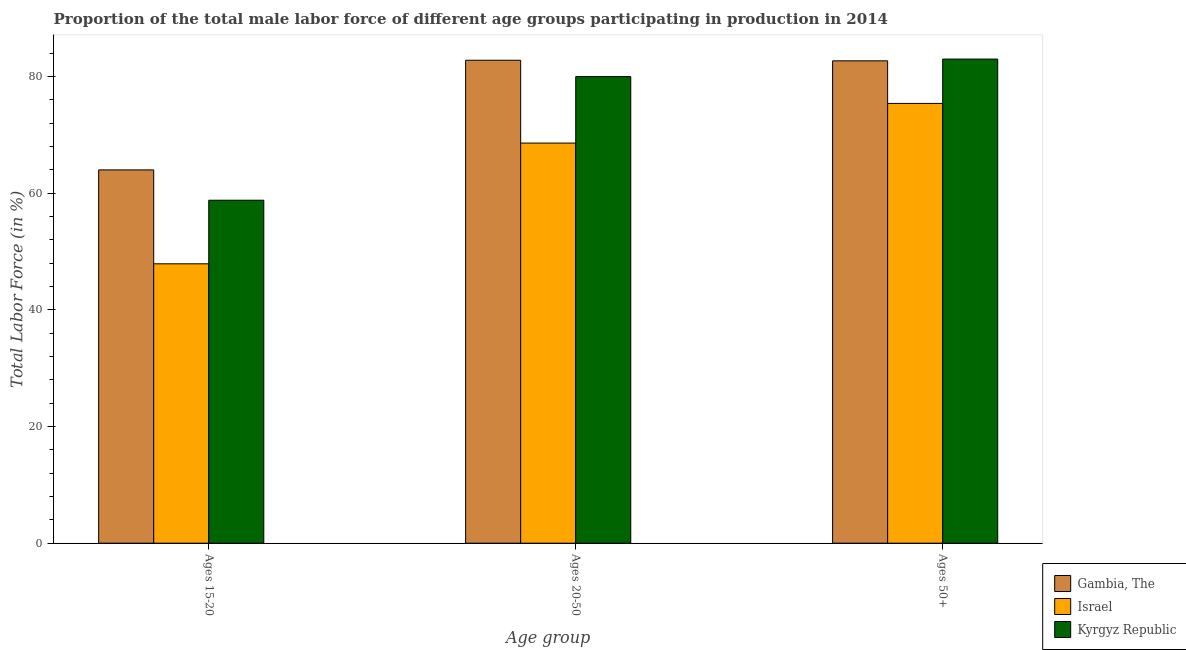Are the number of bars per tick equal to the number of legend labels?
Make the answer very short. Yes. Are the number of bars on each tick of the X-axis equal?
Make the answer very short. Yes. How many bars are there on the 1st tick from the left?
Your response must be concise. 3. How many bars are there on the 2nd tick from the right?
Keep it short and to the point. 3. What is the label of the 1st group of bars from the left?
Ensure brevity in your answer.  Ages 15-20. What is the percentage of male labor force within the age group 15-20 in Kyrgyz Republic?
Your answer should be compact. 58.8. Across all countries, what is the maximum percentage of male labor force within the age group 20-50?
Offer a terse response. 82.8. Across all countries, what is the minimum percentage of male labor force above age 50?
Your response must be concise. 75.4. In which country was the percentage of male labor force above age 50 maximum?
Your answer should be compact. Kyrgyz Republic. In which country was the percentage of male labor force within the age group 15-20 minimum?
Your response must be concise. Israel. What is the total percentage of male labor force within the age group 20-50 in the graph?
Give a very brief answer. 231.4. What is the difference between the percentage of male labor force within the age group 20-50 in Gambia, The and that in Kyrgyz Republic?
Provide a short and direct response. 2.8. What is the difference between the percentage of male labor force within the age group 15-20 in Israel and the percentage of male labor force above age 50 in Gambia, The?
Ensure brevity in your answer.  -34.8. What is the average percentage of male labor force within the age group 15-20 per country?
Keep it short and to the point. 56.9. What is the difference between the percentage of male labor force above age 50 and percentage of male labor force within the age group 15-20 in Gambia, The?
Provide a short and direct response. 18.7. In how many countries, is the percentage of male labor force within the age group 15-20 greater than 80 %?
Your response must be concise. 0. What is the ratio of the percentage of male labor force above age 50 in Israel to that in Kyrgyz Republic?
Offer a terse response. 0.91. Is the difference between the percentage of male labor force within the age group 20-50 in Israel and Gambia, The greater than the difference between the percentage of male labor force above age 50 in Israel and Gambia, The?
Provide a short and direct response. No. What is the difference between the highest and the second highest percentage of male labor force above age 50?
Provide a short and direct response. 0.3. What is the difference between the highest and the lowest percentage of male labor force within the age group 20-50?
Keep it short and to the point. 14.2. In how many countries, is the percentage of male labor force within the age group 15-20 greater than the average percentage of male labor force within the age group 15-20 taken over all countries?
Offer a very short reply. 2. What does the 1st bar from the right in Ages 20-50 represents?
Offer a terse response. Kyrgyz Republic. What is the difference between two consecutive major ticks on the Y-axis?
Provide a short and direct response. 20. Are the values on the major ticks of Y-axis written in scientific E-notation?
Ensure brevity in your answer.  No. How many legend labels are there?
Offer a terse response. 3. How are the legend labels stacked?
Provide a succinct answer. Vertical. What is the title of the graph?
Make the answer very short. Proportion of the total male labor force of different age groups participating in production in 2014. Does "France" appear as one of the legend labels in the graph?
Keep it short and to the point. No. What is the label or title of the X-axis?
Make the answer very short. Age group. What is the label or title of the Y-axis?
Provide a succinct answer. Total Labor Force (in %). What is the Total Labor Force (in %) in Israel in Ages 15-20?
Ensure brevity in your answer.  47.9. What is the Total Labor Force (in %) in Kyrgyz Republic in Ages 15-20?
Offer a terse response. 58.8. What is the Total Labor Force (in %) of Gambia, The in Ages 20-50?
Make the answer very short. 82.8. What is the Total Labor Force (in %) of Israel in Ages 20-50?
Your answer should be very brief. 68.6. What is the Total Labor Force (in %) of Gambia, The in Ages 50+?
Offer a terse response. 82.7. What is the Total Labor Force (in %) of Israel in Ages 50+?
Offer a very short reply. 75.4. Across all Age group, what is the maximum Total Labor Force (in %) of Gambia, The?
Keep it short and to the point. 82.8. Across all Age group, what is the maximum Total Labor Force (in %) of Israel?
Your response must be concise. 75.4. Across all Age group, what is the maximum Total Labor Force (in %) in Kyrgyz Republic?
Provide a short and direct response. 83. Across all Age group, what is the minimum Total Labor Force (in %) of Israel?
Keep it short and to the point. 47.9. Across all Age group, what is the minimum Total Labor Force (in %) in Kyrgyz Republic?
Your answer should be very brief. 58.8. What is the total Total Labor Force (in %) of Gambia, The in the graph?
Ensure brevity in your answer.  229.5. What is the total Total Labor Force (in %) in Israel in the graph?
Your answer should be compact. 191.9. What is the total Total Labor Force (in %) in Kyrgyz Republic in the graph?
Your response must be concise. 221.8. What is the difference between the Total Labor Force (in %) of Gambia, The in Ages 15-20 and that in Ages 20-50?
Ensure brevity in your answer.  -18.8. What is the difference between the Total Labor Force (in %) of Israel in Ages 15-20 and that in Ages 20-50?
Make the answer very short. -20.7. What is the difference between the Total Labor Force (in %) of Kyrgyz Republic in Ages 15-20 and that in Ages 20-50?
Provide a short and direct response. -21.2. What is the difference between the Total Labor Force (in %) in Gambia, The in Ages 15-20 and that in Ages 50+?
Offer a terse response. -18.7. What is the difference between the Total Labor Force (in %) in Israel in Ages 15-20 and that in Ages 50+?
Offer a very short reply. -27.5. What is the difference between the Total Labor Force (in %) of Kyrgyz Republic in Ages 15-20 and that in Ages 50+?
Make the answer very short. -24.2. What is the difference between the Total Labor Force (in %) in Israel in Ages 20-50 and that in Ages 50+?
Ensure brevity in your answer.  -6.8. What is the difference between the Total Labor Force (in %) in Gambia, The in Ages 15-20 and the Total Labor Force (in %) in Israel in Ages 20-50?
Your response must be concise. -4.6. What is the difference between the Total Labor Force (in %) in Israel in Ages 15-20 and the Total Labor Force (in %) in Kyrgyz Republic in Ages 20-50?
Offer a terse response. -32.1. What is the difference between the Total Labor Force (in %) of Gambia, The in Ages 15-20 and the Total Labor Force (in %) of Kyrgyz Republic in Ages 50+?
Give a very brief answer. -19. What is the difference between the Total Labor Force (in %) in Israel in Ages 15-20 and the Total Labor Force (in %) in Kyrgyz Republic in Ages 50+?
Your answer should be very brief. -35.1. What is the difference between the Total Labor Force (in %) of Gambia, The in Ages 20-50 and the Total Labor Force (in %) of Israel in Ages 50+?
Provide a succinct answer. 7.4. What is the difference between the Total Labor Force (in %) in Israel in Ages 20-50 and the Total Labor Force (in %) in Kyrgyz Republic in Ages 50+?
Offer a very short reply. -14.4. What is the average Total Labor Force (in %) in Gambia, The per Age group?
Provide a short and direct response. 76.5. What is the average Total Labor Force (in %) of Israel per Age group?
Offer a terse response. 63.97. What is the average Total Labor Force (in %) of Kyrgyz Republic per Age group?
Provide a succinct answer. 73.93. What is the difference between the Total Labor Force (in %) in Israel and Total Labor Force (in %) in Kyrgyz Republic in Ages 15-20?
Give a very brief answer. -10.9. What is the difference between the Total Labor Force (in %) in Israel and Total Labor Force (in %) in Kyrgyz Republic in Ages 20-50?
Offer a very short reply. -11.4. What is the difference between the Total Labor Force (in %) of Gambia, The and Total Labor Force (in %) of Israel in Ages 50+?
Give a very brief answer. 7.3. What is the difference between the Total Labor Force (in %) of Gambia, The and Total Labor Force (in %) of Kyrgyz Republic in Ages 50+?
Provide a succinct answer. -0.3. What is the difference between the Total Labor Force (in %) in Israel and Total Labor Force (in %) in Kyrgyz Republic in Ages 50+?
Your answer should be very brief. -7.6. What is the ratio of the Total Labor Force (in %) in Gambia, The in Ages 15-20 to that in Ages 20-50?
Provide a succinct answer. 0.77. What is the ratio of the Total Labor Force (in %) in Israel in Ages 15-20 to that in Ages 20-50?
Provide a succinct answer. 0.7. What is the ratio of the Total Labor Force (in %) in Kyrgyz Republic in Ages 15-20 to that in Ages 20-50?
Keep it short and to the point. 0.73. What is the ratio of the Total Labor Force (in %) of Gambia, The in Ages 15-20 to that in Ages 50+?
Make the answer very short. 0.77. What is the ratio of the Total Labor Force (in %) in Israel in Ages 15-20 to that in Ages 50+?
Offer a terse response. 0.64. What is the ratio of the Total Labor Force (in %) in Kyrgyz Republic in Ages 15-20 to that in Ages 50+?
Offer a very short reply. 0.71. What is the ratio of the Total Labor Force (in %) of Gambia, The in Ages 20-50 to that in Ages 50+?
Your answer should be compact. 1. What is the ratio of the Total Labor Force (in %) of Israel in Ages 20-50 to that in Ages 50+?
Make the answer very short. 0.91. What is the ratio of the Total Labor Force (in %) of Kyrgyz Republic in Ages 20-50 to that in Ages 50+?
Make the answer very short. 0.96. What is the difference between the highest and the second highest Total Labor Force (in %) of Kyrgyz Republic?
Ensure brevity in your answer.  3. What is the difference between the highest and the lowest Total Labor Force (in %) of Gambia, The?
Provide a short and direct response. 18.8. What is the difference between the highest and the lowest Total Labor Force (in %) in Kyrgyz Republic?
Offer a very short reply. 24.2. 